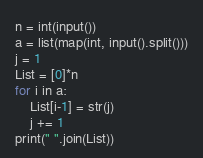Convert code to text. <code><loc_0><loc_0><loc_500><loc_500><_Python_>n = int(input())
a = list(map(int, input().split()))
j = 1
List = [0]*n
for i in a:
    List[i-1] = str(j)
    j += 1 
print(" ".join(List))</code> 